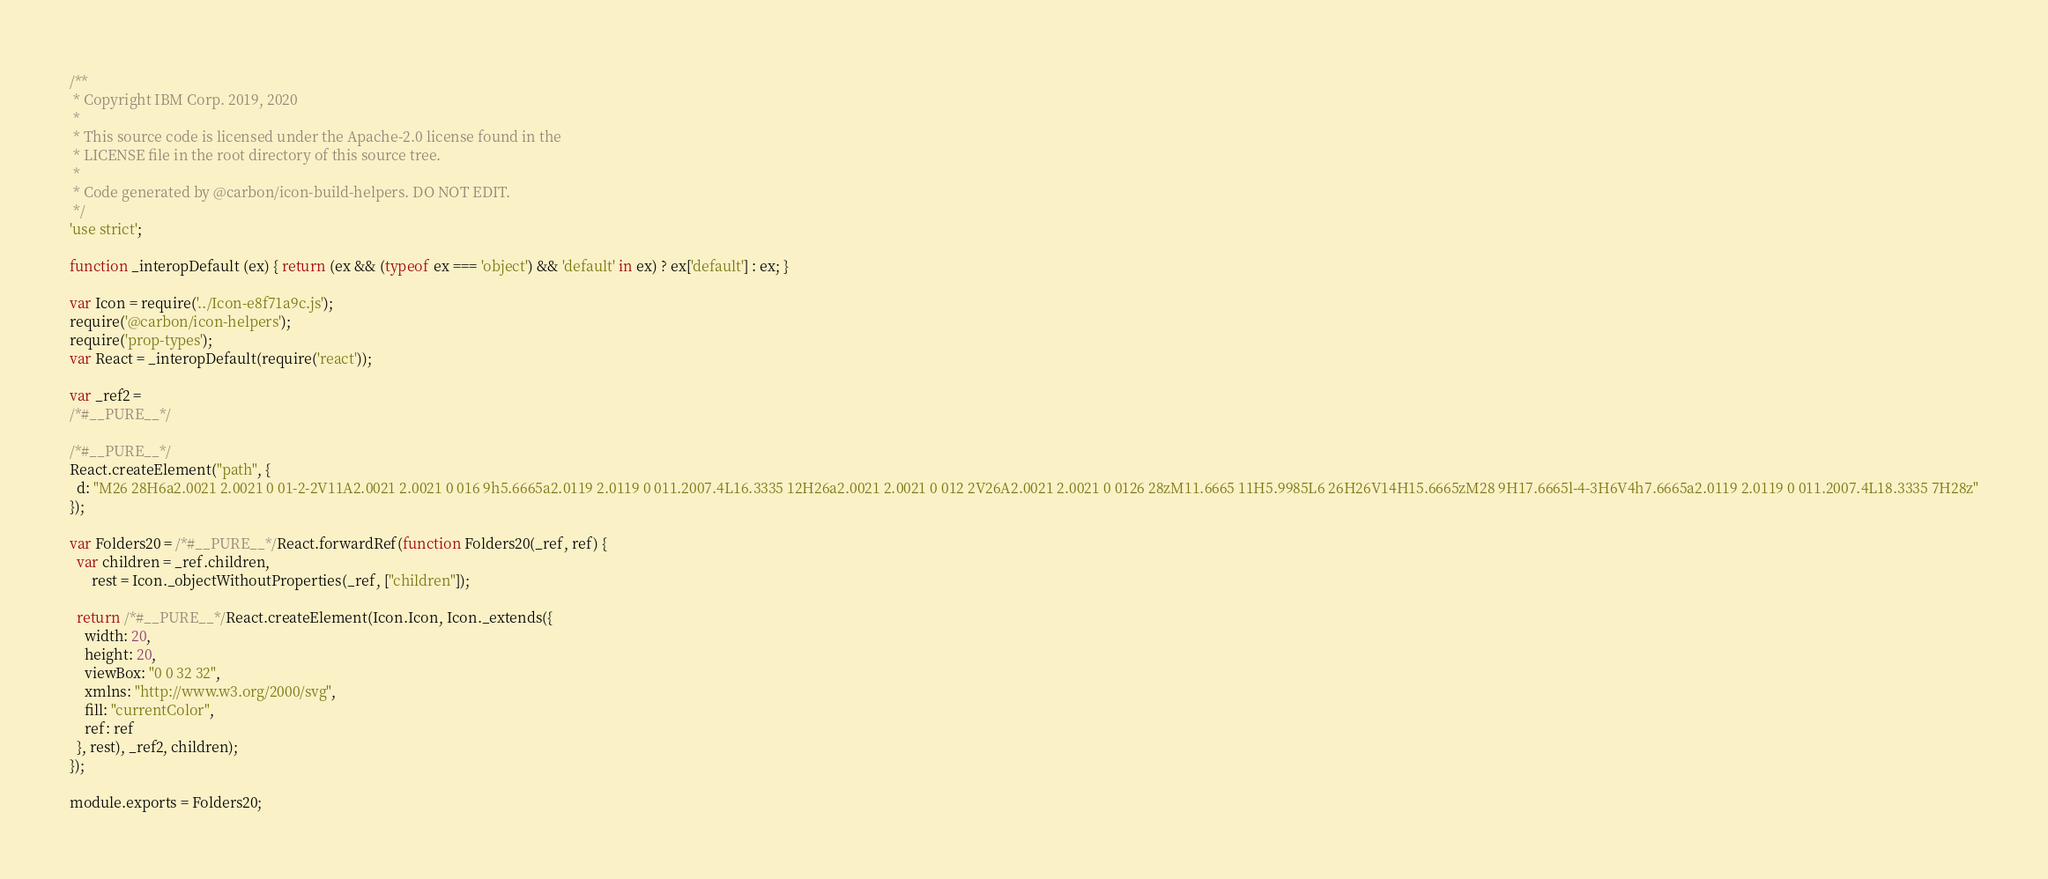Convert code to text. <code><loc_0><loc_0><loc_500><loc_500><_JavaScript_>/**
 * Copyright IBM Corp. 2019, 2020
 *
 * This source code is licensed under the Apache-2.0 license found in the
 * LICENSE file in the root directory of this source tree.
 *
 * Code generated by @carbon/icon-build-helpers. DO NOT EDIT.
 */
'use strict';

function _interopDefault (ex) { return (ex && (typeof ex === 'object') && 'default' in ex) ? ex['default'] : ex; }

var Icon = require('../Icon-e8f71a9c.js');
require('@carbon/icon-helpers');
require('prop-types');
var React = _interopDefault(require('react'));

var _ref2 =
/*#__PURE__*/

/*#__PURE__*/
React.createElement("path", {
  d: "M26 28H6a2.0021 2.0021 0 01-2-2V11A2.0021 2.0021 0 016 9h5.6665a2.0119 2.0119 0 011.2007.4L16.3335 12H26a2.0021 2.0021 0 012 2V26A2.0021 2.0021 0 0126 28zM11.6665 11H5.9985L6 26H26V14H15.6665zM28 9H17.6665l-4-3H6V4h7.6665a2.0119 2.0119 0 011.2007.4L18.3335 7H28z"
});

var Folders20 = /*#__PURE__*/React.forwardRef(function Folders20(_ref, ref) {
  var children = _ref.children,
      rest = Icon._objectWithoutProperties(_ref, ["children"]);

  return /*#__PURE__*/React.createElement(Icon.Icon, Icon._extends({
    width: 20,
    height: 20,
    viewBox: "0 0 32 32",
    xmlns: "http://www.w3.org/2000/svg",
    fill: "currentColor",
    ref: ref
  }, rest), _ref2, children);
});

module.exports = Folders20;
</code> 